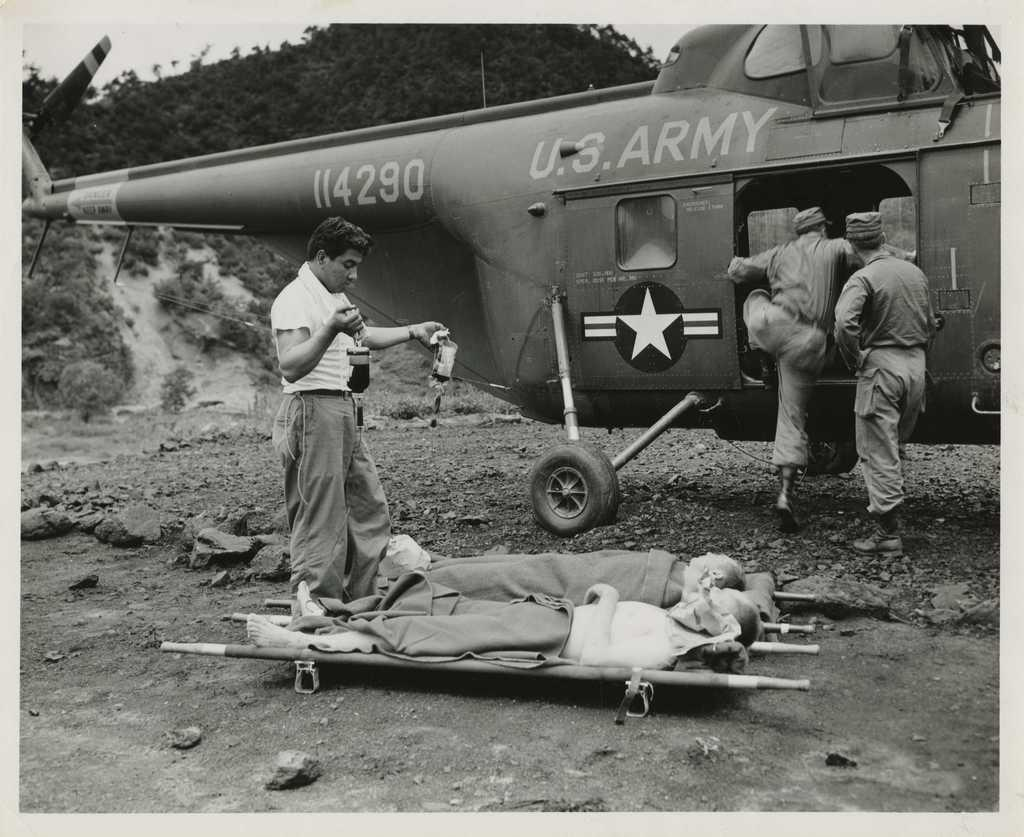<image>
Write a terse but informative summary of the picture. Men about to transport two other men onto a U.S. Army helicopter. 